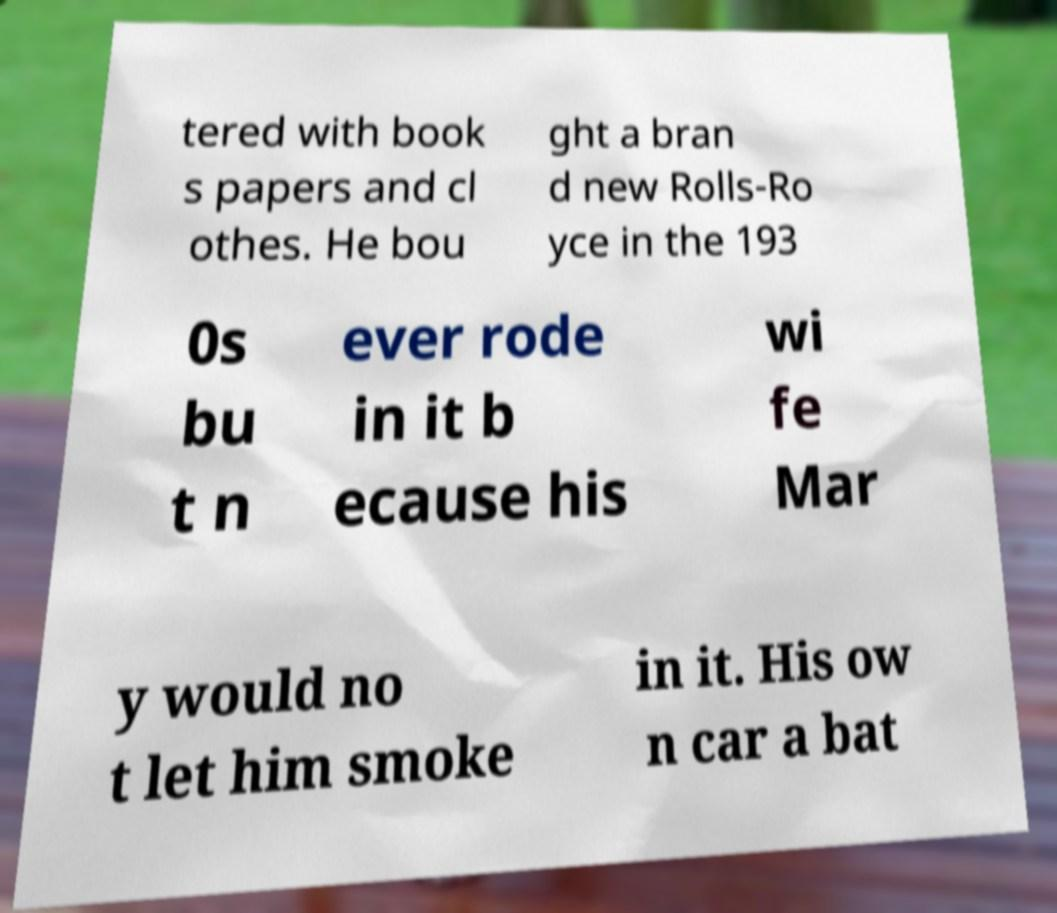Can you read and provide the text displayed in the image?This photo seems to have some interesting text. Can you extract and type it out for me? tered with book s papers and cl othes. He bou ght a bran d new Rolls-Ro yce in the 193 0s bu t n ever rode in it b ecause his wi fe Mar y would no t let him smoke in it. His ow n car a bat 